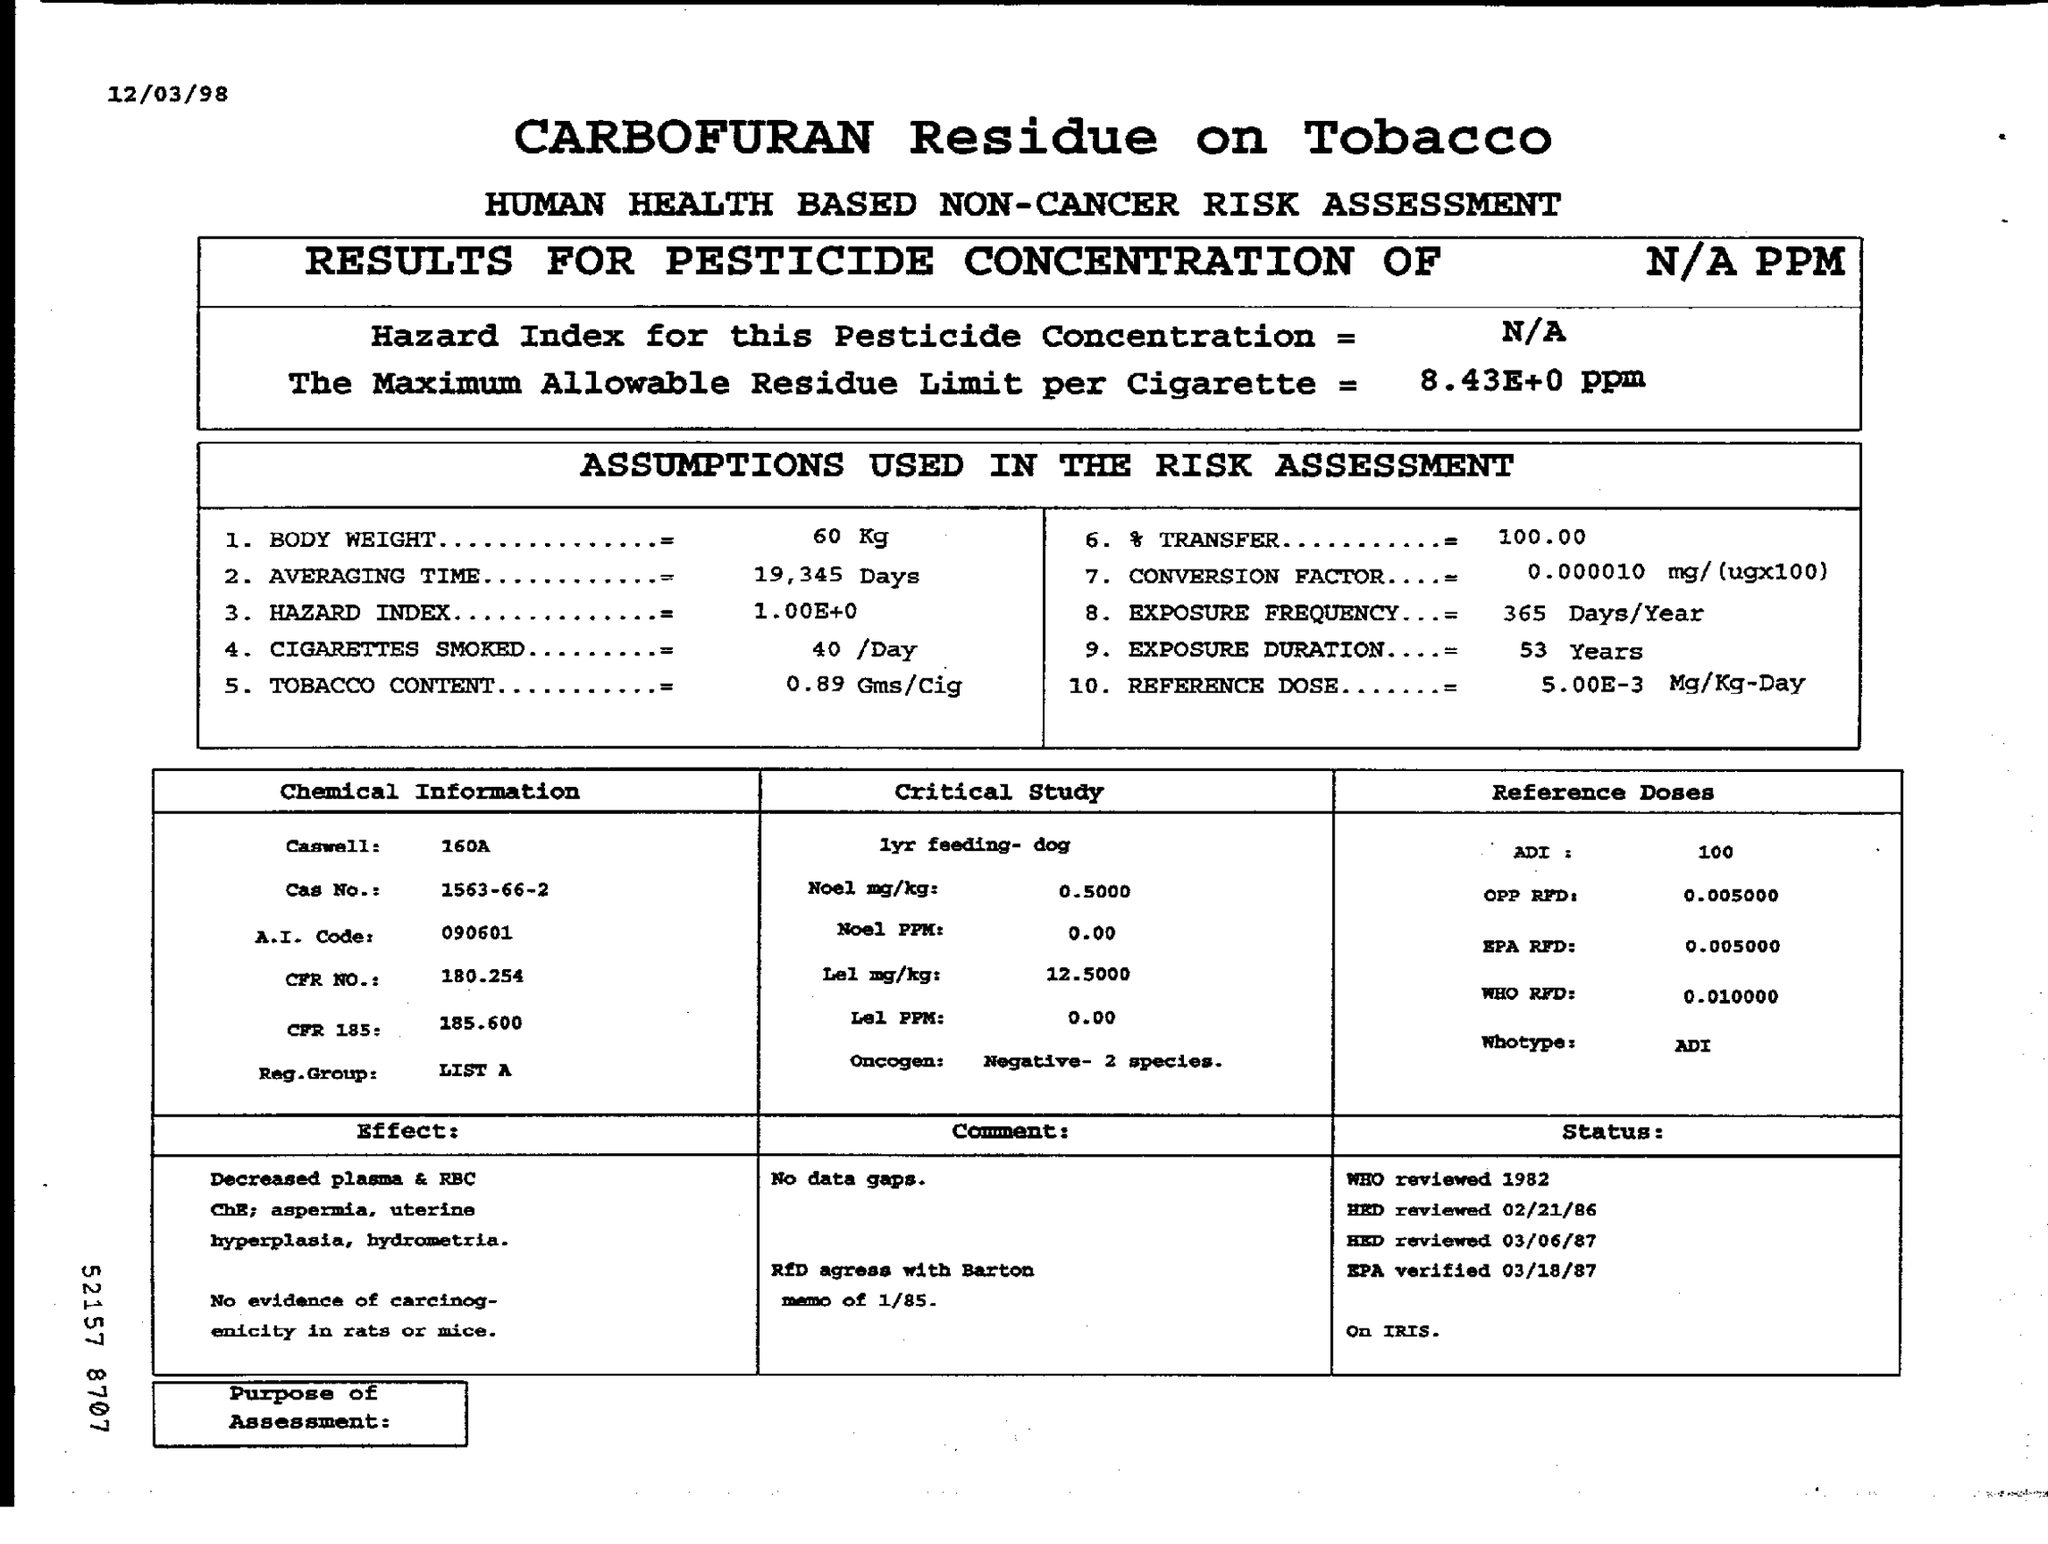Can you explain what the Maximum Allowable Residue Limit and Hazard Index indicate in this document? The Maximum Allowable Residue Limit (8.43±0 ppm) indicates the highest concentration of pesticide residues legally allowed in tobacco products, set to protect consumers. The Hazard Index (1.004±0) is a ratio comparing exposure to a substance with the level at which no adverse effects are expected; a value close to or exceeding 1 suggests potential health risks. 